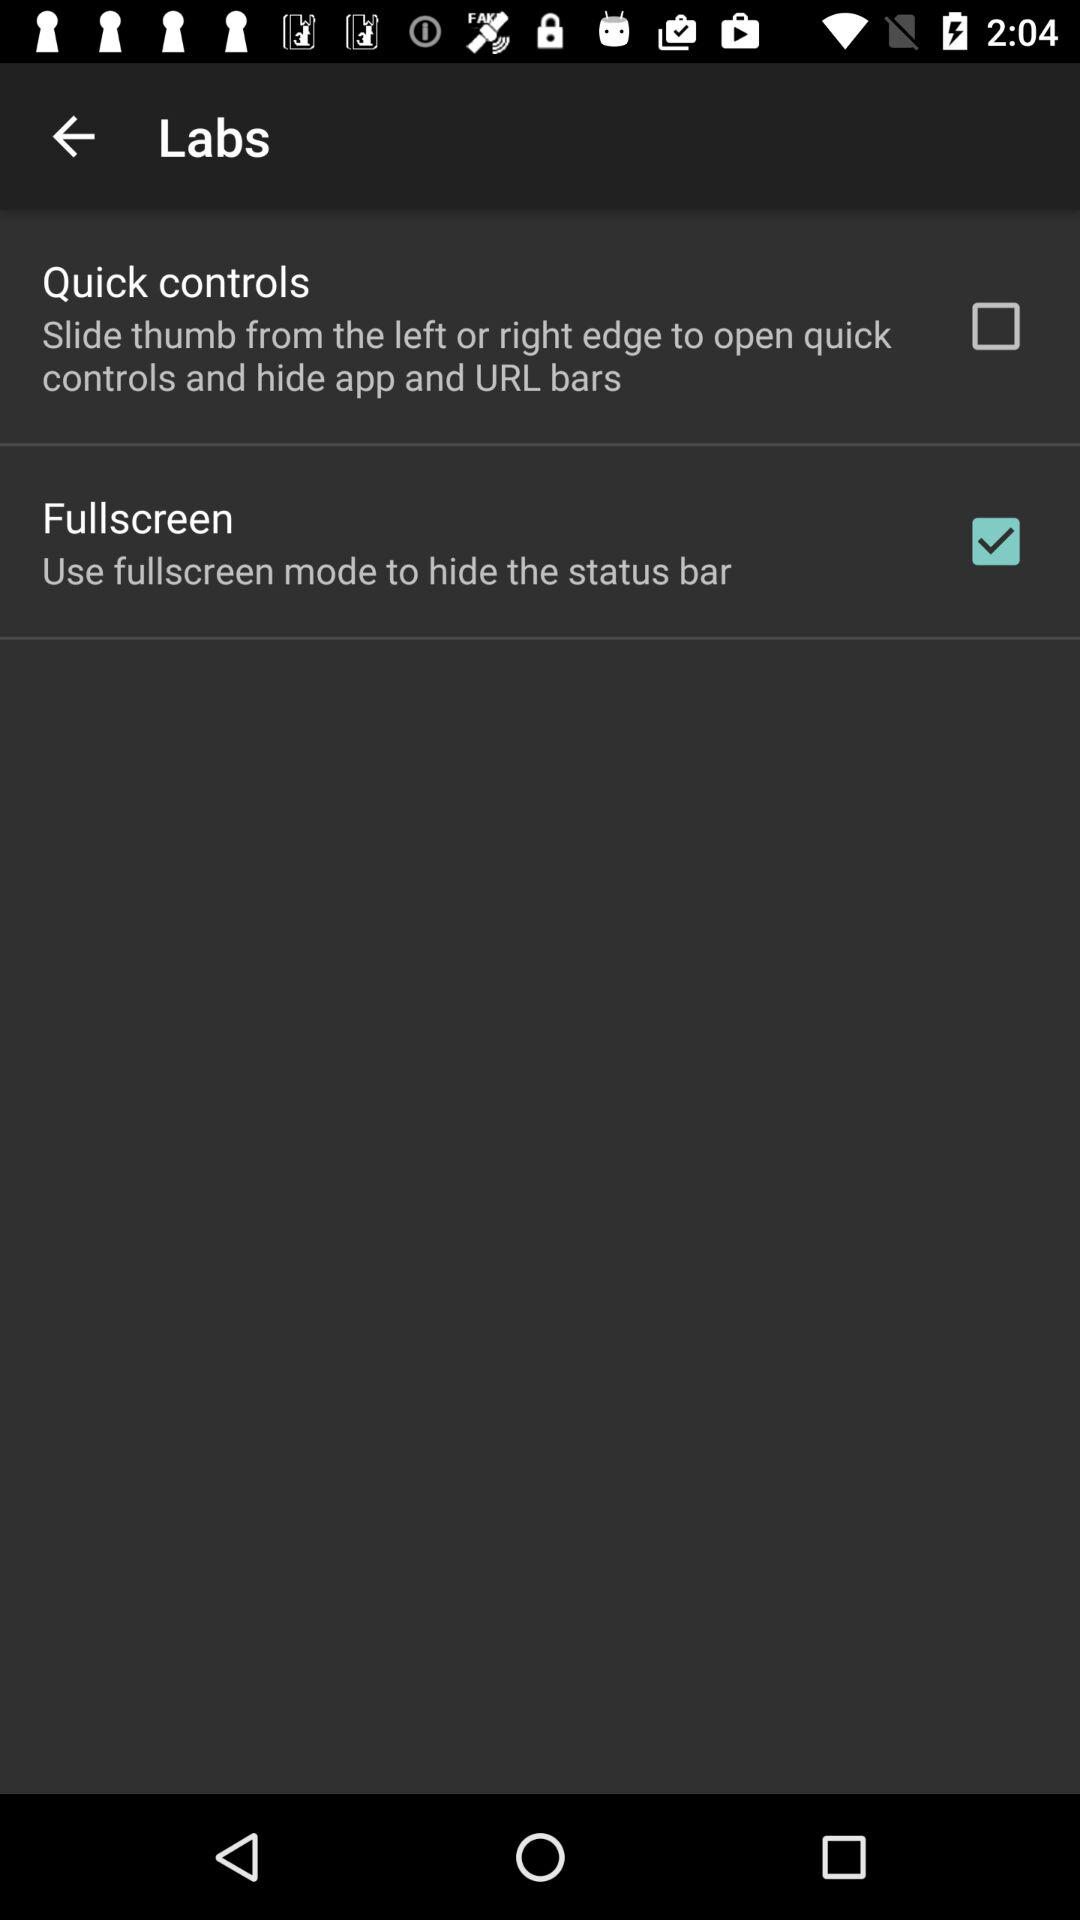What is the status of the "Quick controls"? The status is "off". 